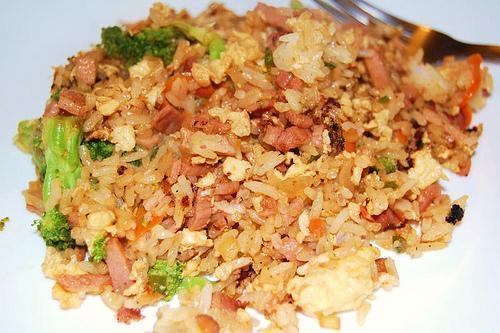How many broccolis are in the picture?
Give a very brief answer. 2. 